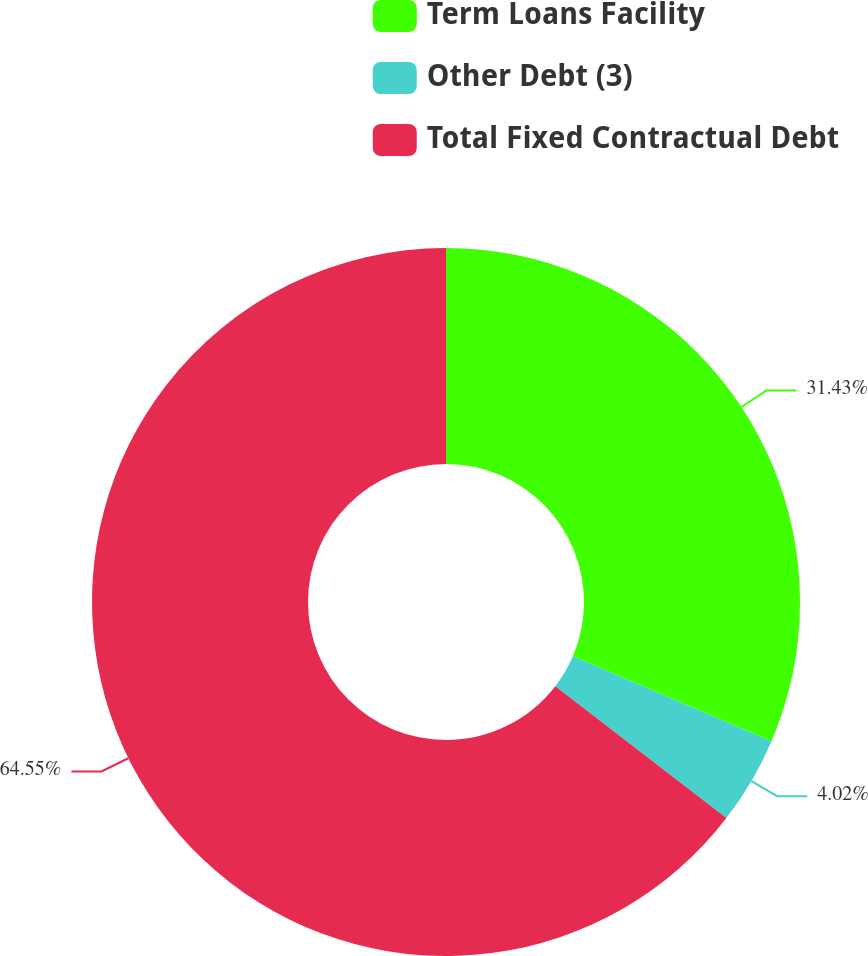<chart> <loc_0><loc_0><loc_500><loc_500><pie_chart><fcel>Term Loans Facility<fcel>Other Debt (3)<fcel>Total Fixed Contractual Debt<nl><fcel>31.43%<fcel>4.02%<fcel>64.55%<nl></chart> 